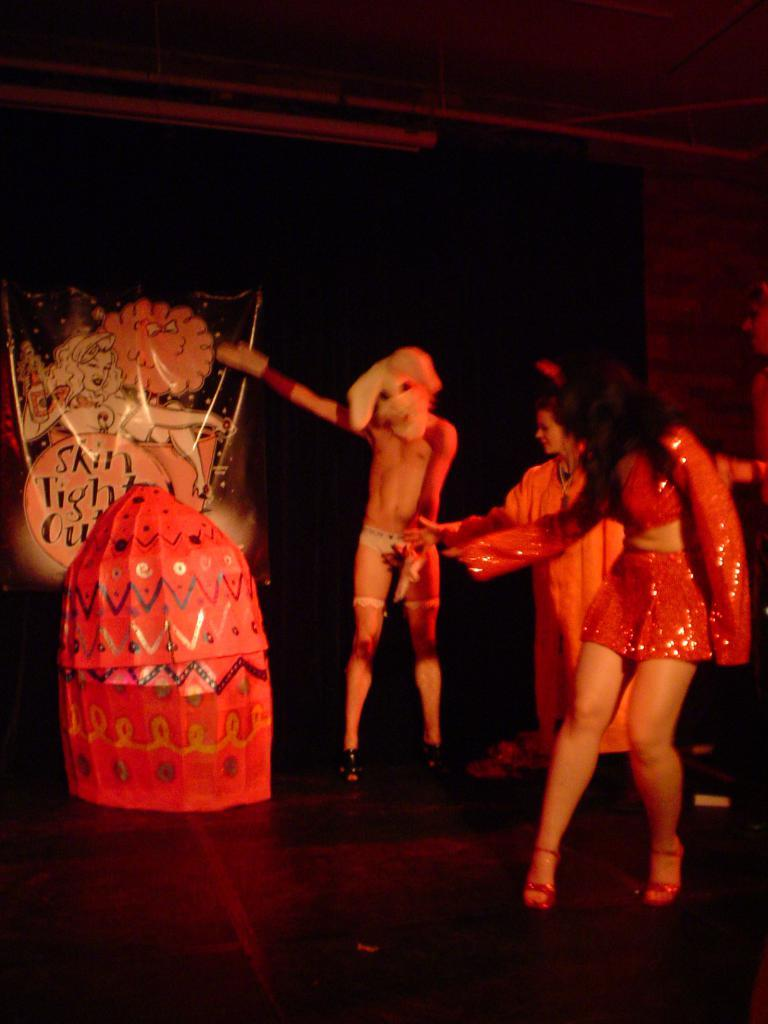What is happening in the image? There are people standing in the image. What color is the prominent object in the image? There is a red object in the image. What is hanging in the background of the image? There is a banner in the image. What information is displayed on the banner? There is text written on the banner. What is the price of the loaf of bread in the image? There is no loaf of bread present in the image, so it is not possible to determine its price. 